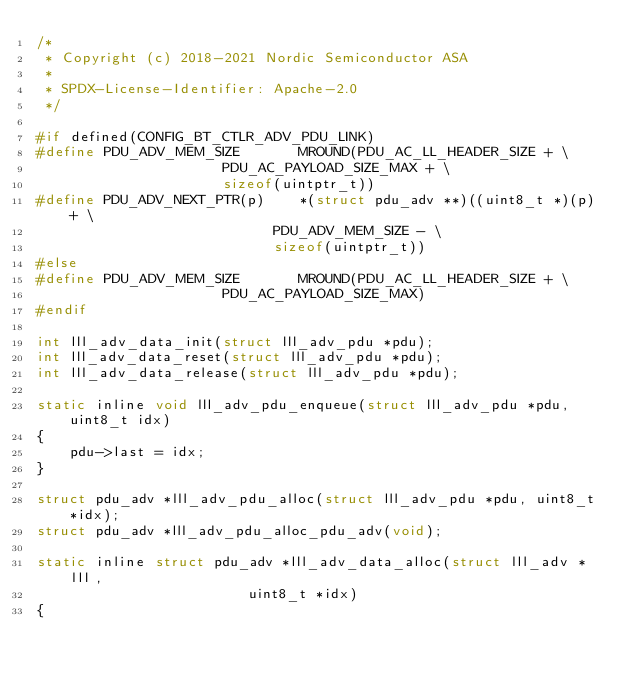Convert code to text. <code><loc_0><loc_0><loc_500><loc_500><_C_>/*
 * Copyright (c) 2018-2021 Nordic Semiconductor ASA
 *
 * SPDX-License-Identifier: Apache-2.0
 */

#if defined(CONFIG_BT_CTLR_ADV_PDU_LINK)
#define PDU_ADV_MEM_SIZE       MROUND(PDU_AC_LL_HEADER_SIZE + \
				      PDU_AC_PAYLOAD_SIZE_MAX + \
				      sizeof(uintptr_t))
#define PDU_ADV_NEXT_PTR(p)    *(struct pdu_adv **)((uint8_t *)(p) + \
						    PDU_ADV_MEM_SIZE - \
						    sizeof(uintptr_t))
#else
#define PDU_ADV_MEM_SIZE       MROUND(PDU_AC_LL_HEADER_SIZE + \
				      PDU_AC_PAYLOAD_SIZE_MAX)
#endif

int lll_adv_data_init(struct lll_adv_pdu *pdu);
int lll_adv_data_reset(struct lll_adv_pdu *pdu);
int lll_adv_data_release(struct lll_adv_pdu *pdu);

static inline void lll_adv_pdu_enqueue(struct lll_adv_pdu *pdu, uint8_t idx)
{
	pdu->last = idx;
}

struct pdu_adv *lll_adv_pdu_alloc(struct lll_adv_pdu *pdu, uint8_t *idx);
struct pdu_adv *lll_adv_pdu_alloc_pdu_adv(void);

static inline struct pdu_adv *lll_adv_data_alloc(struct lll_adv *lll,
						 uint8_t *idx)
{</code> 